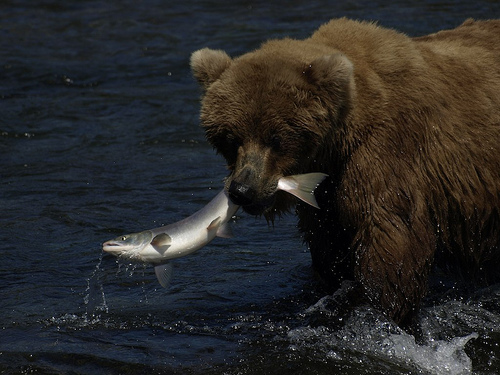How does the habitat in the background inform you about where this might be taking place? The bear is surrounded by water, and the backdrop appears to be a riverine environment, which suggests this could be near a river or a coastal area commonly found in parts of North America where brown bears are known to fish for salmon. 